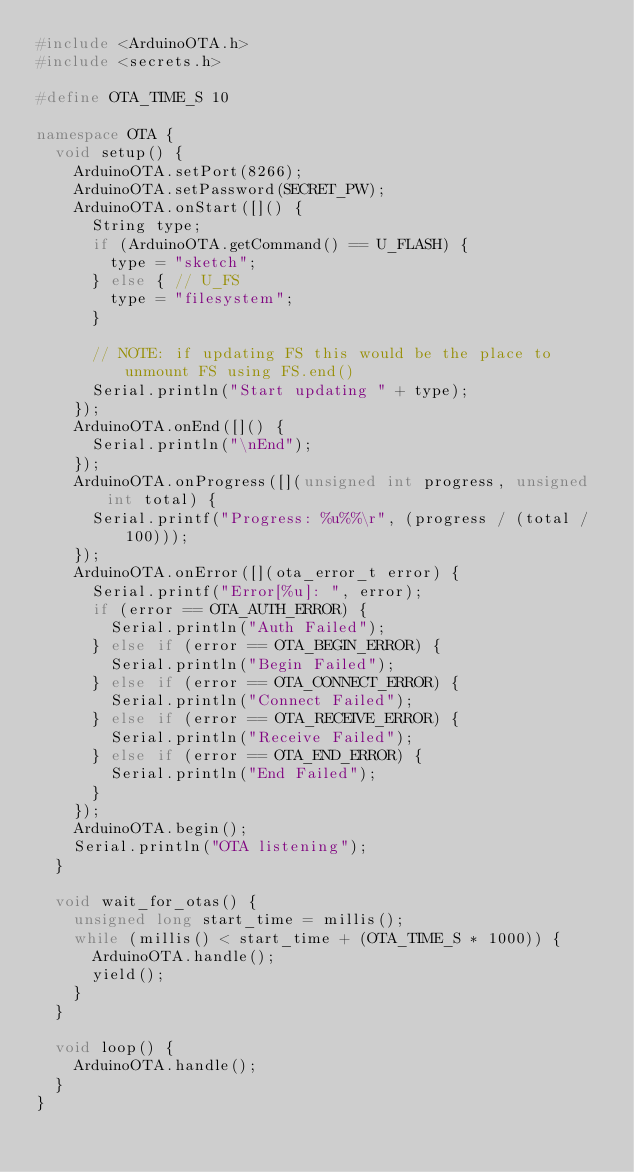Convert code to text. <code><loc_0><loc_0><loc_500><loc_500><_C++_>#include <ArduinoOTA.h>
#include <secrets.h>

#define OTA_TIME_S 10

namespace OTA {
	void setup() {
		ArduinoOTA.setPort(8266);
		ArduinoOTA.setPassword(SECRET_PW);
		ArduinoOTA.onStart([]() {
			String type;
			if (ArduinoOTA.getCommand() == U_FLASH) {
				type = "sketch";
			} else { // U_FS
				type = "filesystem";
			}

			// NOTE: if updating FS this would be the place to unmount FS using FS.end()
			Serial.println("Start updating " + type);
		});
		ArduinoOTA.onEnd([]() {
			Serial.println("\nEnd");
		});
		ArduinoOTA.onProgress([](unsigned int progress, unsigned int total) {
			Serial.printf("Progress: %u%%\r", (progress / (total / 100)));
		});
		ArduinoOTA.onError([](ota_error_t error) {
			Serial.printf("Error[%u]: ", error);
			if (error == OTA_AUTH_ERROR) {
				Serial.println("Auth Failed");
			} else if (error == OTA_BEGIN_ERROR) {
				Serial.println("Begin Failed");
			} else if (error == OTA_CONNECT_ERROR) {
				Serial.println("Connect Failed");
			} else if (error == OTA_RECEIVE_ERROR) {
				Serial.println("Receive Failed");
			} else if (error == OTA_END_ERROR) {
				Serial.println("End Failed");
			}
		});
		ArduinoOTA.begin();
		Serial.println("OTA listening");
	}
	
	void wait_for_otas() {
		unsigned long start_time = millis();
		while (millis() < start_time + (OTA_TIME_S * 1000)) {
			ArduinoOTA.handle();
			yield();
		}
	}

	void loop() {
		ArduinoOTA.handle();
	}
}</code> 